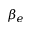<formula> <loc_0><loc_0><loc_500><loc_500>\beta _ { e }</formula> 